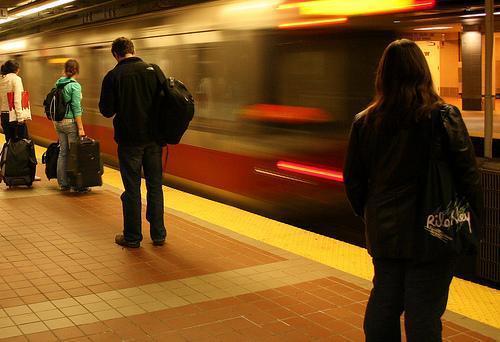How many people are there?
Give a very brief answer. 4. 